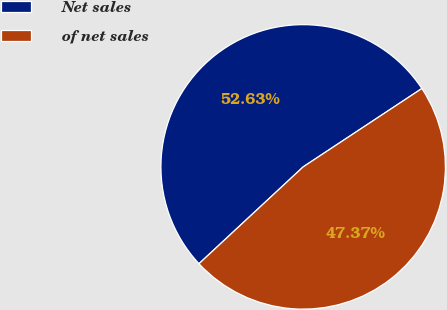Convert chart to OTSL. <chart><loc_0><loc_0><loc_500><loc_500><pie_chart><fcel>Net sales<fcel>of net sales<nl><fcel>52.63%<fcel>47.37%<nl></chart> 